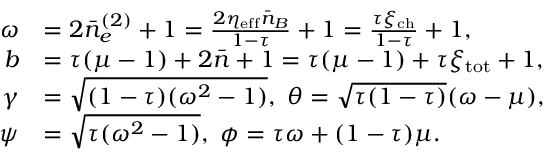Convert formula to latex. <formula><loc_0><loc_0><loc_500><loc_500>\begin{array} { r l } { \omega } & { = 2 \bar { n } _ { e } ^ { ( 2 ) } + 1 = \frac { 2 \eta _ { e f f } \bar { n } _ { B } } { 1 - \tau } + 1 = \frac { \tau \xi _ { c h } } { 1 - \tau } + 1 , } \\ { b } & { = \tau ( \mu - 1 ) + 2 \bar { n } + 1 = \tau ( \mu - 1 ) + \tau \xi _ { t o t } + 1 , } \\ { \gamma } & { = \sqrt { ( 1 - \tau ) ( \omega ^ { 2 } - 1 ) } , \theta = \sqrt { \tau ( 1 - \tau ) } ( \omega - \mu ) , } \\ { \psi } & { = \sqrt { \tau ( \omega ^ { 2 } - 1 ) } , \phi = \tau \omega + ( 1 - \tau ) \mu . } \end{array}</formula> 